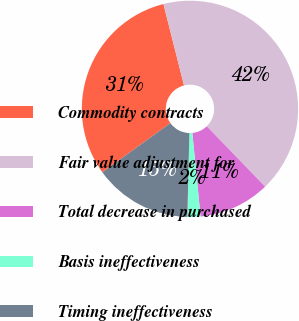<chart> <loc_0><loc_0><loc_500><loc_500><pie_chart><fcel>Commodity contracts<fcel>Fair value adjustment for<fcel>Total decrease in purchased<fcel>Basis ineffectiveness<fcel>Timing ineffectiveness<nl><fcel>31.03%<fcel>41.71%<fcel>10.67%<fcel>1.94%<fcel>14.65%<nl></chart> 